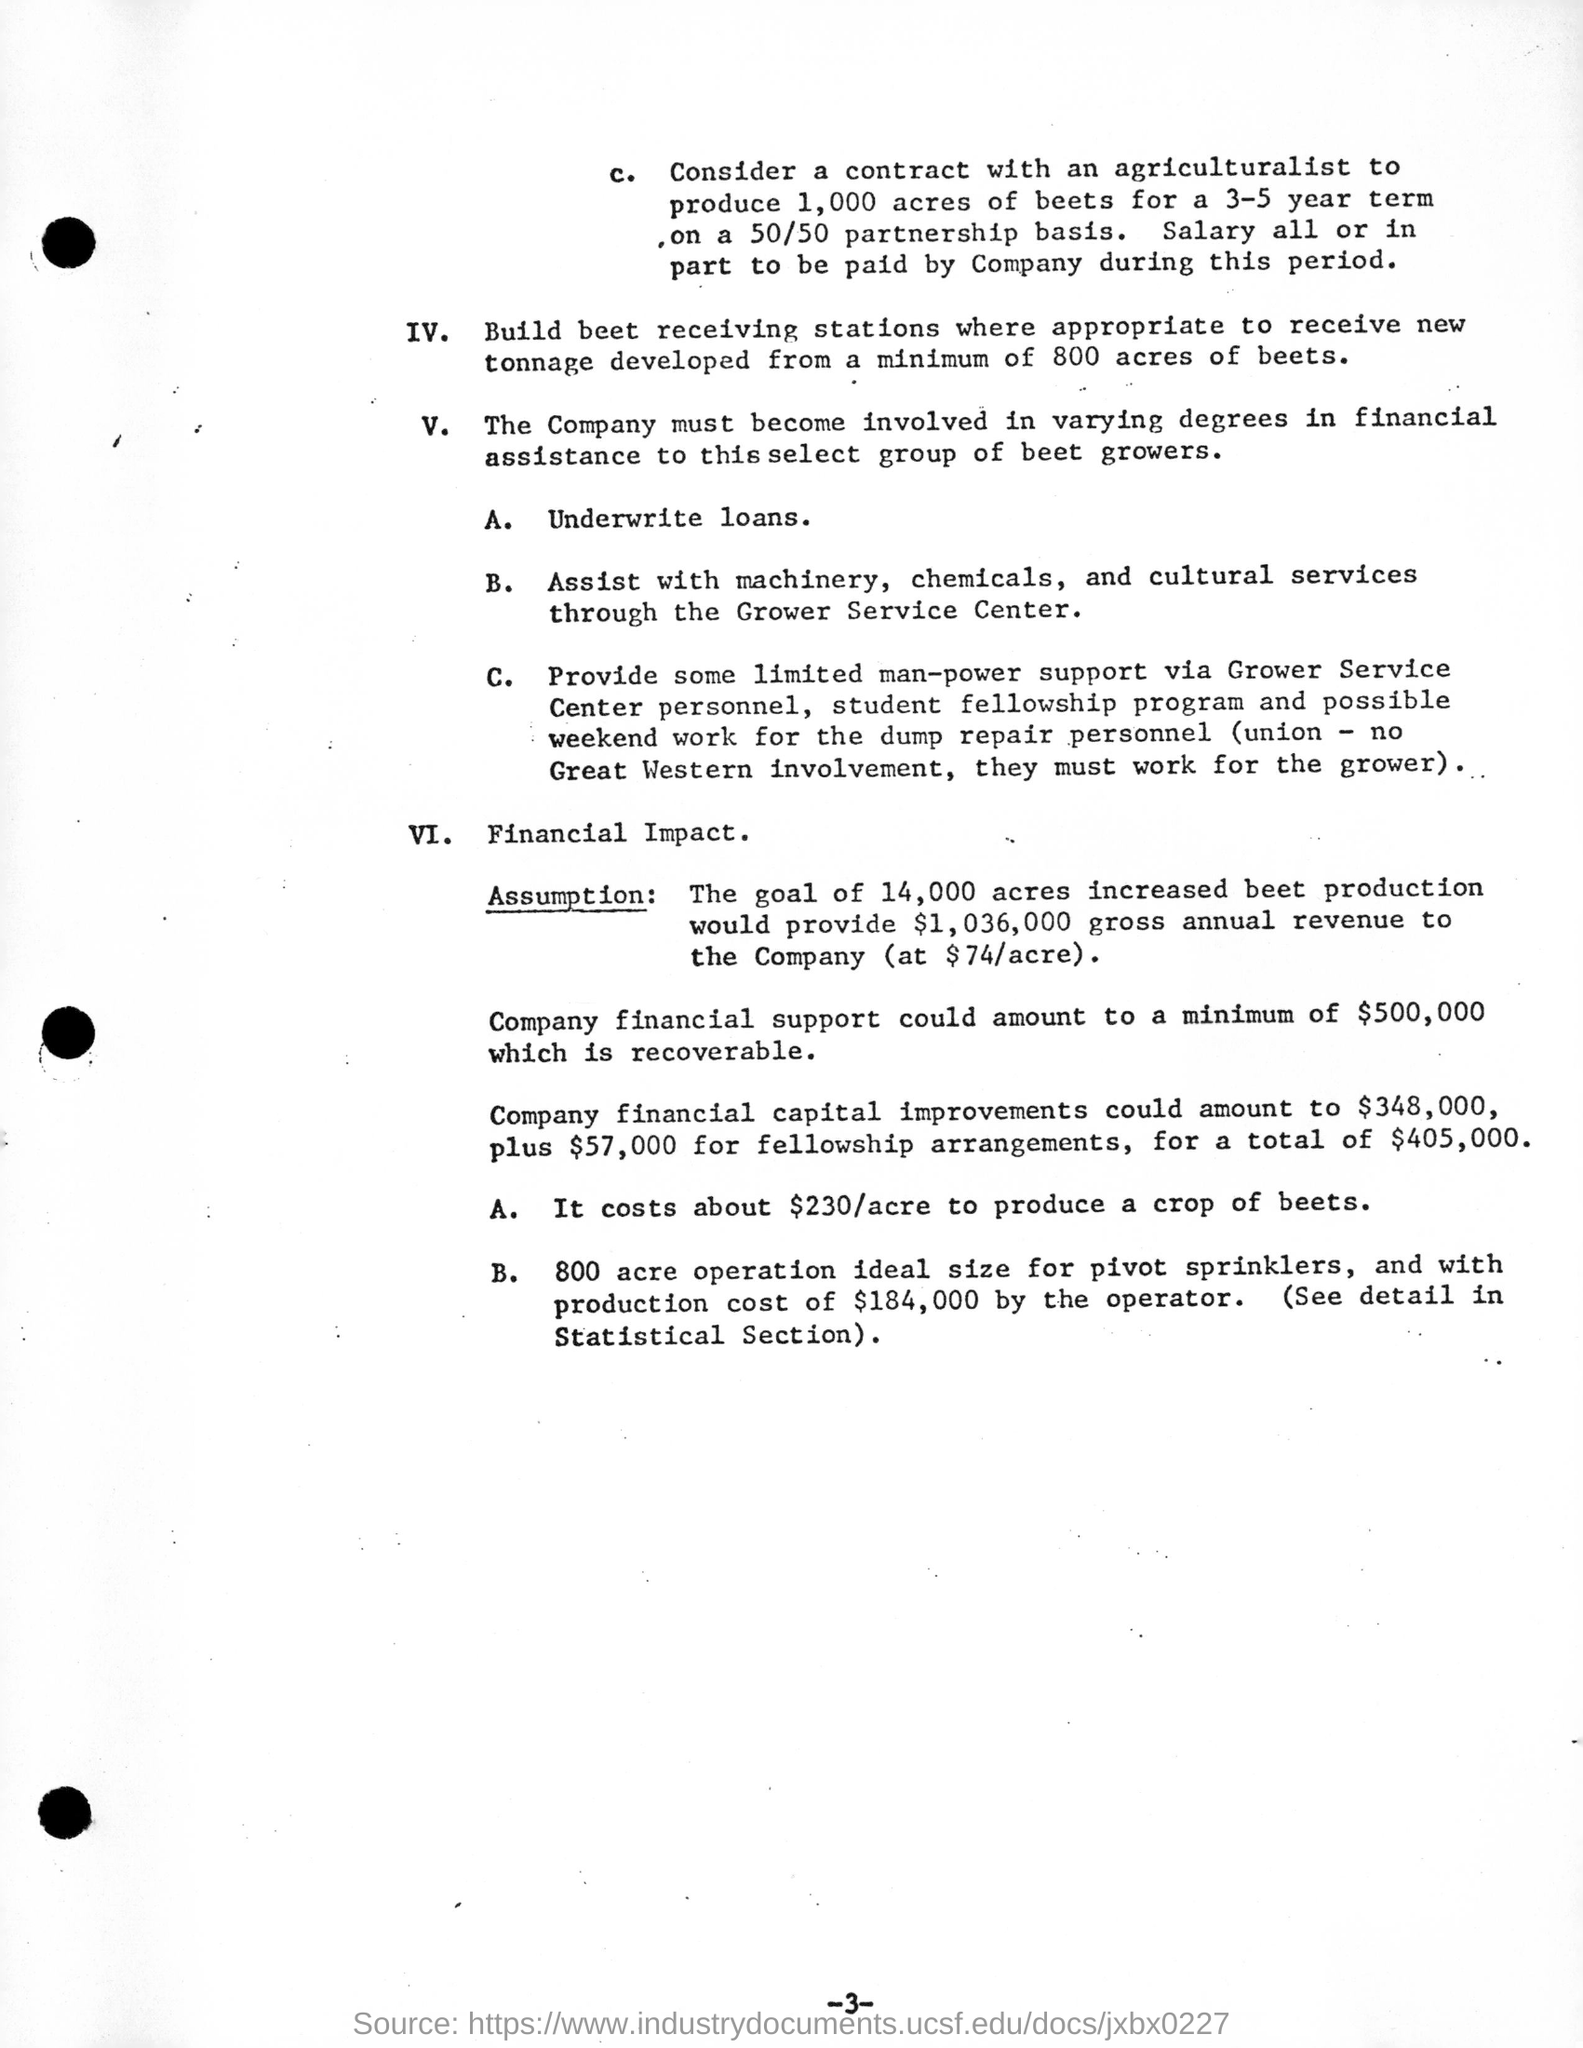What is the Page Number?
Make the answer very short. 3. 